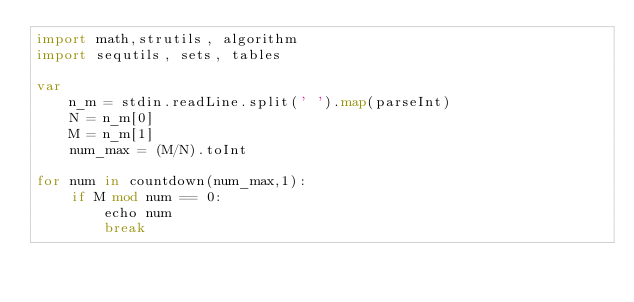<code> <loc_0><loc_0><loc_500><loc_500><_Nim_>import math,strutils, algorithm
import sequtils, sets, tables

var
    n_m = stdin.readLine.split(' ').map(parseInt)
    N = n_m[0]
    M = n_m[1]
    num_max = (M/N).toInt

for num in countdown(num_max,1):
    if M mod num == 0:
        echo num
        break
</code> 